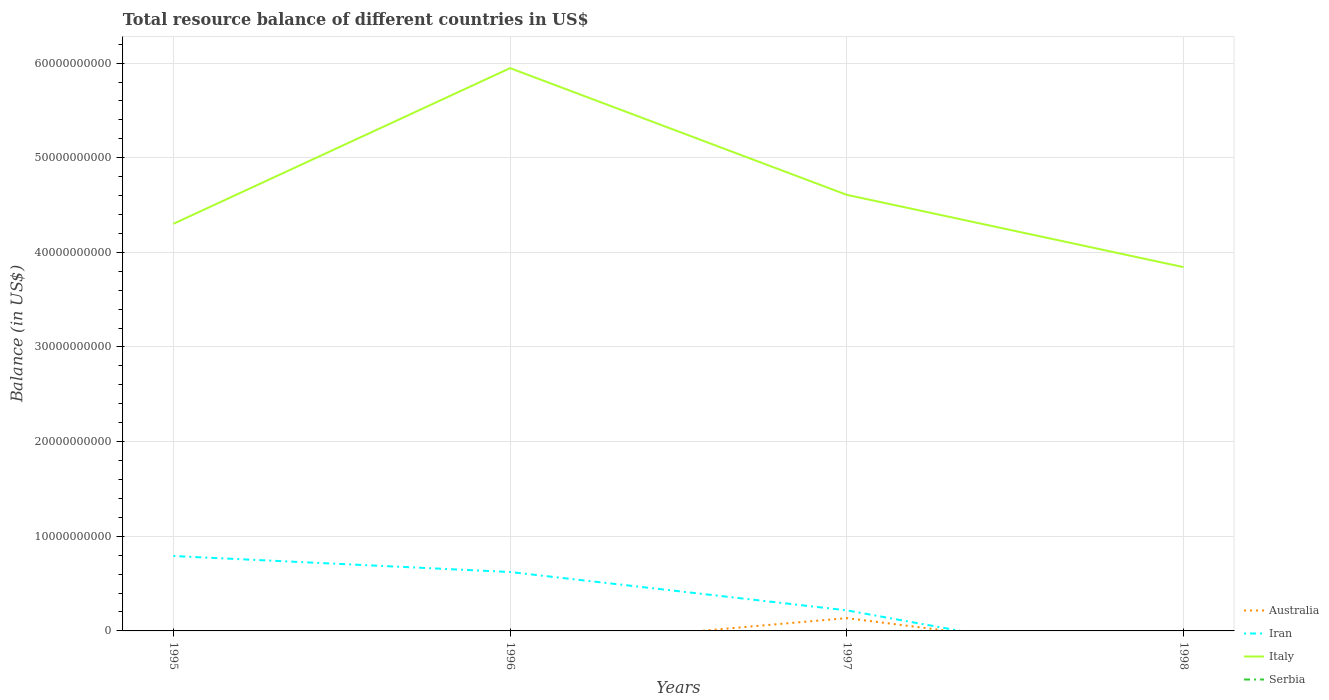How many different coloured lines are there?
Provide a succinct answer. 3. What is the total total resource balance in Italy in the graph?
Provide a succinct answer. -3.06e+09. What is the difference between the highest and the second highest total resource balance in Italy?
Your response must be concise. 2.10e+1. Is the total resource balance in Serbia strictly greater than the total resource balance in Italy over the years?
Your answer should be very brief. Yes. What is the difference between two consecutive major ticks on the Y-axis?
Your answer should be compact. 1.00e+1. Are the values on the major ticks of Y-axis written in scientific E-notation?
Provide a short and direct response. No. How are the legend labels stacked?
Give a very brief answer. Vertical. What is the title of the graph?
Ensure brevity in your answer.  Total resource balance of different countries in US$. Does "Libya" appear as one of the legend labels in the graph?
Offer a very short reply. No. What is the label or title of the X-axis?
Give a very brief answer. Years. What is the label or title of the Y-axis?
Make the answer very short. Balance (in US$). What is the Balance (in US$) of Australia in 1995?
Provide a short and direct response. 0. What is the Balance (in US$) in Iran in 1995?
Ensure brevity in your answer.  7.91e+09. What is the Balance (in US$) of Italy in 1995?
Give a very brief answer. 4.30e+1. What is the Balance (in US$) in Iran in 1996?
Your answer should be very brief. 6.22e+09. What is the Balance (in US$) of Italy in 1996?
Provide a succinct answer. 5.95e+1. What is the Balance (in US$) in Serbia in 1996?
Ensure brevity in your answer.  0. What is the Balance (in US$) in Australia in 1997?
Keep it short and to the point. 1.35e+09. What is the Balance (in US$) of Iran in 1997?
Keep it short and to the point. 2.17e+09. What is the Balance (in US$) of Italy in 1997?
Provide a succinct answer. 4.61e+1. What is the Balance (in US$) of Serbia in 1997?
Provide a short and direct response. 0. What is the Balance (in US$) of Australia in 1998?
Keep it short and to the point. 0. What is the Balance (in US$) of Iran in 1998?
Make the answer very short. 0. What is the Balance (in US$) of Italy in 1998?
Offer a very short reply. 3.84e+1. Across all years, what is the maximum Balance (in US$) of Australia?
Your answer should be compact. 1.35e+09. Across all years, what is the maximum Balance (in US$) of Iran?
Provide a succinct answer. 7.91e+09. Across all years, what is the maximum Balance (in US$) of Italy?
Provide a short and direct response. 5.95e+1. Across all years, what is the minimum Balance (in US$) in Italy?
Your answer should be compact. 3.84e+1. What is the total Balance (in US$) of Australia in the graph?
Provide a short and direct response. 1.35e+09. What is the total Balance (in US$) in Iran in the graph?
Your response must be concise. 1.63e+1. What is the total Balance (in US$) of Italy in the graph?
Your answer should be compact. 1.87e+11. What is the difference between the Balance (in US$) in Iran in 1995 and that in 1996?
Your answer should be compact. 1.69e+09. What is the difference between the Balance (in US$) in Italy in 1995 and that in 1996?
Give a very brief answer. -1.65e+1. What is the difference between the Balance (in US$) of Iran in 1995 and that in 1997?
Ensure brevity in your answer.  5.74e+09. What is the difference between the Balance (in US$) of Italy in 1995 and that in 1997?
Provide a succinct answer. -3.06e+09. What is the difference between the Balance (in US$) of Italy in 1995 and that in 1998?
Provide a succinct answer. 4.58e+09. What is the difference between the Balance (in US$) in Iran in 1996 and that in 1997?
Offer a terse response. 4.05e+09. What is the difference between the Balance (in US$) in Italy in 1996 and that in 1997?
Provide a succinct answer. 1.34e+1. What is the difference between the Balance (in US$) in Italy in 1996 and that in 1998?
Provide a short and direct response. 2.10e+1. What is the difference between the Balance (in US$) of Italy in 1997 and that in 1998?
Provide a short and direct response. 7.64e+09. What is the difference between the Balance (in US$) in Iran in 1995 and the Balance (in US$) in Italy in 1996?
Provide a short and direct response. -5.16e+1. What is the difference between the Balance (in US$) in Iran in 1995 and the Balance (in US$) in Italy in 1997?
Ensure brevity in your answer.  -3.82e+1. What is the difference between the Balance (in US$) in Iran in 1995 and the Balance (in US$) in Italy in 1998?
Your answer should be very brief. -3.05e+1. What is the difference between the Balance (in US$) of Iran in 1996 and the Balance (in US$) of Italy in 1997?
Your answer should be very brief. -3.99e+1. What is the difference between the Balance (in US$) of Iran in 1996 and the Balance (in US$) of Italy in 1998?
Provide a short and direct response. -3.22e+1. What is the difference between the Balance (in US$) in Australia in 1997 and the Balance (in US$) in Italy in 1998?
Offer a very short reply. -3.71e+1. What is the difference between the Balance (in US$) in Iran in 1997 and the Balance (in US$) in Italy in 1998?
Keep it short and to the point. -3.63e+1. What is the average Balance (in US$) in Australia per year?
Your answer should be very brief. 3.38e+08. What is the average Balance (in US$) in Iran per year?
Give a very brief answer. 4.08e+09. What is the average Balance (in US$) in Italy per year?
Make the answer very short. 4.67e+1. What is the average Balance (in US$) of Serbia per year?
Give a very brief answer. 0. In the year 1995, what is the difference between the Balance (in US$) of Iran and Balance (in US$) of Italy?
Your response must be concise. -3.51e+1. In the year 1996, what is the difference between the Balance (in US$) of Iran and Balance (in US$) of Italy?
Make the answer very short. -5.32e+1. In the year 1997, what is the difference between the Balance (in US$) of Australia and Balance (in US$) of Iran?
Your answer should be very brief. -8.18e+08. In the year 1997, what is the difference between the Balance (in US$) of Australia and Balance (in US$) of Italy?
Keep it short and to the point. -4.47e+1. In the year 1997, what is the difference between the Balance (in US$) of Iran and Balance (in US$) of Italy?
Keep it short and to the point. -4.39e+1. What is the ratio of the Balance (in US$) in Iran in 1995 to that in 1996?
Your answer should be compact. 1.27. What is the ratio of the Balance (in US$) in Italy in 1995 to that in 1996?
Give a very brief answer. 0.72. What is the ratio of the Balance (in US$) of Iran in 1995 to that in 1997?
Ensure brevity in your answer.  3.64. What is the ratio of the Balance (in US$) of Italy in 1995 to that in 1997?
Your answer should be compact. 0.93. What is the ratio of the Balance (in US$) in Italy in 1995 to that in 1998?
Your response must be concise. 1.12. What is the ratio of the Balance (in US$) in Iran in 1996 to that in 1997?
Offer a terse response. 2.87. What is the ratio of the Balance (in US$) in Italy in 1996 to that in 1997?
Offer a terse response. 1.29. What is the ratio of the Balance (in US$) of Italy in 1996 to that in 1998?
Keep it short and to the point. 1.55. What is the ratio of the Balance (in US$) of Italy in 1997 to that in 1998?
Ensure brevity in your answer.  1.2. What is the difference between the highest and the second highest Balance (in US$) in Iran?
Provide a short and direct response. 1.69e+09. What is the difference between the highest and the second highest Balance (in US$) in Italy?
Your answer should be compact. 1.34e+1. What is the difference between the highest and the lowest Balance (in US$) of Australia?
Keep it short and to the point. 1.35e+09. What is the difference between the highest and the lowest Balance (in US$) in Iran?
Make the answer very short. 7.91e+09. What is the difference between the highest and the lowest Balance (in US$) of Italy?
Make the answer very short. 2.10e+1. 